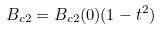Convert formula to latex. <formula><loc_0><loc_0><loc_500><loc_500>B _ { c 2 } = B _ { c 2 } ( 0 ) ( 1 - t ^ { 2 } )</formula> 